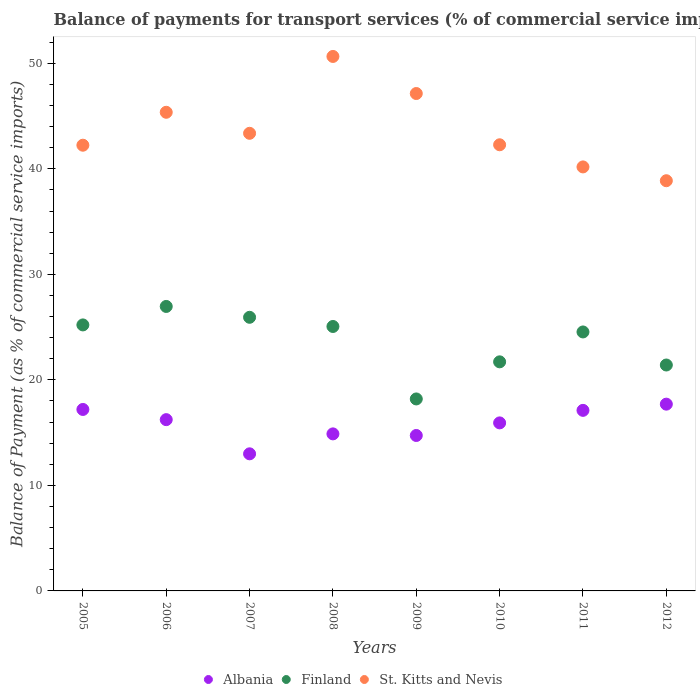Is the number of dotlines equal to the number of legend labels?
Keep it short and to the point. Yes. What is the balance of payments for transport services in Albania in 2008?
Provide a succinct answer. 14.88. Across all years, what is the maximum balance of payments for transport services in Albania?
Your answer should be very brief. 17.7. Across all years, what is the minimum balance of payments for transport services in Albania?
Offer a very short reply. 12.99. What is the total balance of payments for transport services in Albania in the graph?
Keep it short and to the point. 126.78. What is the difference between the balance of payments for transport services in Albania in 2009 and that in 2010?
Keep it short and to the point. -1.19. What is the difference between the balance of payments for transport services in St. Kitts and Nevis in 2006 and the balance of payments for transport services in Finland in 2012?
Give a very brief answer. 23.95. What is the average balance of payments for transport services in St. Kitts and Nevis per year?
Provide a short and direct response. 43.76. In the year 2012, what is the difference between the balance of payments for transport services in Albania and balance of payments for transport services in St. Kitts and Nevis?
Keep it short and to the point. -21.18. What is the ratio of the balance of payments for transport services in Finland in 2009 to that in 2011?
Provide a succinct answer. 0.74. Is the balance of payments for transport services in Albania in 2008 less than that in 2012?
Provide a succinct answer. Yes. Is the difference between the balance of payments for transport services in Albania in 2007 and 2008 greater than the difference between the balance of payments for transport services in St. Kitts and Nevis in 2007 and 2008?
Keep it short and to the point. Yes. What is the difference between the highest and the second highest balance of payments for transport services in St. Kitts and Nevis?
Give a very brief answer. 3.51. What is the difference between the highest and the lowest balance of payments for transport services in St. Kitts and Nevis?
Offer a terse response. 11.78. Is it the case that in every year, the sum of the balance of payments for transport services in Finland and balance of payments for transport services in Albania  is greater than the balance of payments for transport services in St. Kitts and Nevis?
Your answer should be compact. No. Is the balance of payments for transport services in Albania strictly greater than the balance of payments for transport services in Finland over the years?
Provide a short and direct response. No. Is the balance of payments for transport services in Finland strictly less than the balance of payments for transport services in St. Kitts and Nevis over the years?
Your answer should be compact. Yes. Are the values on the major ticks of Y-axis written in scientific E-notation?
Keep it short and to the point. No. Does the graph contain any zero values?
Your answer should be very brief. No. Where does the legend appear in the graph?
Your response must be concise. Bottom center. How are the legend labels stacked?
Keep it short and to the point. Horizontal. What is the title of the graph?
Ensure brevity in your answer.  Balance of payments for transport services (% of commercial service imports). What is the label or title of the X-axis?
Provide a succinct answer. Years. What is the label or title of the Y-axis?
Keep it short and to the point. Balance of Payment (as % of commercial service imports). What is the Balance of Payment (as % of commercial service imports) of Albania in 2005?
Your answer should be very brief. 17.2. What is the Balance of Payment (as % of commercial service imports) in Finland in 2005?
Your answer should be compact. 25.21. What is the Balance of Payment (as % of commercial service imports) in St. Kitts and Nevis in 2005?
Keep it short and to the point. 42.24. What is the Balance of Payment (as % of commercial service imports) in Albania in 2006?
Provide a succinct answer. 16.23. What is the Balance of Payment (as % of commercial service imports) in Finland in 2006?
Offer a terse response. 26.96. What is the Balance of Payment (as % of commercial service imports) in St. Kitts and Nevis in 2006?
Your answer should be compact. 45.36. What is the Balance of Payment (as % of commercial service imports) in Albania in 2007?
Offer a terse response. 12.99. What is the Balance of Payment (as % of commercial service imports) of Finland in 2007?
Your response must be concise. 25.93. What is the Balance of Payment (as % of commercial service imports) in St. Kitts and Nevis in 2007?
Provide a succinct answer. 43.37. What is the Balance of Payment (as % of commercial service imports) in Albania in 2008?
Your response must be concise. 14.88. What is the Balance of Payment (as % of commercial service imports) of Finland in 2008?
Offer a very short reply. 25.06. What is the Balance of Payment (as % of commercial service imports) of St. Kitts and Nevis in 2008?
Provide a short and direct response. 50.65. What is the Balance of Payment (as % of commercial service imports) of Albania in 2009?
Give a very brief answer. 14.73. What is the Balance of Payment (as % of commercial service imports) of Finland in 2009?
Provide a succinct answer. 18.19. What is the Balance of Payment (as % of commercial service imports) in St. Kitts and Nevis in 2009?
Provide a short and direct response. 47.14. What is the Balance of Payment (as % of commercial service imports) in Albania in 2010?
Provide a succinct answer. 15.93. What is the Balance of Payment (as % of commercial service imports) of Finland in 2010?
Your answer should be compact. 21.71. What is the Balance of Payment (as % of commercial service imports) of St. Kitts and Nevis in 2010?
Offer a terse response. 42.28. What is the Balance of Payment (as % of commercial service imports) of Albania in 2011?
Give a very brief answer. 17.11. What is the Balance of Payment (as % of commercial service imports) of Finland in 2011?
Provide a short and direct response. 24.54. What is the Balance of Payment (as % of commercial service imports) in St. Kitts and Nevis in 2011?
Keep it short and to the point. 40.18. What is the Balance of Payment (as % of commercial service imports) of Albania in 2012?
Your answer should be compact. 17.7. What is the Balance of Payment (as % of commercial service imports) of Finland in 2012?
Offer a very short reply. 21.41. What is the Balance of Payment (as % of commercial service imports) of St. Kitts and Nevis in 2012?
Make the answer very short. 38.88. Across all years, what is the maximum Balance of Payment (as % of commercial service imports) of Albania?
Ensure brevity in your answer.  17.7. Across all years, what is the maximum Balance of Payment (as % of commercial service imports) in Finland?
Your answer should be very brief. 26.96. Across all years, what is the maximum Balance of Payment (as % of commercial service imports) of St. Kitts and Nevis?
Offer a terse response. 50.65. Across all years, what is the minimum Balance of Payment (as % of commercial service imports) of Albania?
Offer a very short reply. 12.99. Across all years, what is the minimum Balance of Payment (as % of commercial service imports) of Finland?
Ensure brevity in your answer.  18.19. Across all years, what is the minimum Balance of Payment (as % of commercial service imports) in St. Kitts and Nevis?
Offer a very short reply. 38.88. What is the total Balance of Payment (as % of commercial service imports) in Albania in the graph?
Ensure brevity in your answer.  126.78. What is the total Balance of Payment (as % of commercial service imports) in Finland in the graph?
Keep it short and to the point. 189.03. What is the total Balance of Payment (as % of commercial service imports) of St. Kitts and Nevis in the graph?
Offer a very short reply. 350.11. What is the difference between the Balance of Payment (as % of commercial service imports) of Albania in 2005 and that in 2006?
Your response must be concise. 0.97. What is the difference between the Balance of Payment (as % of commercial service imports) in Finland in 2005 and that in 2006?
Provide a succinct answer. -1.75. What is the difference between the Balance of Payment (as % of commercial service imports) of St. Kitts and Nevis in 2005 and that in 2006?
Make the answer very short. -3.12. What is the difference between the Balance of Payment (as % of commercial service imports) of Albania in 2005 and that in 2007?
Ensure brevity in your answer.  4.2. What is the difference between the Balance of Payment (as % of commercial service imports) in Finland in 2005 and that in 2007?
Ensure brevity in your answer.  -0.72. What is the difference between the Balance of Payment (as % of commercial service imports) of St. Kitts and Nevis in 2005 and that in 2007?
Offer a terse response. -1.13. What is the difference between the Balance of Payment (as % of commercial service imports) of Albania in 2005 and that in 2008?
Your response must be concise. 2.31. What is the difference between the Balance of Payment (as % of commercial service imports) of Finland in 2005 and that in 2008?
Your answer should be compact. 0.15. What is the difference between the Balance of Payment (as % of commercial service imports) in St. Kitts and Nevis in 2005 and that in 2008?
Your answer should be compact. -8.41. What is the difference between the Balance of Payment (as % of commercial service imports) in Albania in 2005 and that in 2009?
Offer a terse response. 2.47. What is the difference between the Balance of Payment (as % of commercial service imports) of Finland in 2005 and that in 2009?
Ensure brevity in your answer.  7.02. What is the difference between the Balance of Payment (as % of commercial service imports) in St. Kitts and Nevis in 2005 and that in 2009?
Your answer should be very brief. -4.9. What is the difference between the Balance of Payment (as % of commercial service imports) in Albania in 2005 and that in 2010?
Make the answer very short. 1.27. What is the difference between the Balance of Payment (as % of commercial service imports) in Finland in 2005 and that in 2010?
Your answer should be compact. 3.5. What is the difference between the Balance of Payment (as % of commercial service imports) in St. Kitts and Nevis in 2005 and that in 2010?
Make the answer very short. -0.04. What is the difference between the Balance of Payment (as % of commercial service imports) in Albania in 2005 and that in 2011?
Offer a very short reply. 0.09. What is the difference between the Balance of Payment (as % of commercial service imports) of Finland in 2005 and that in 2011?
Keep it short and to the point. 0.67. What is the difference between the Balance of Payment (as % of commercial service imports) of St. Kitts and Nevis in 2005 and that in 2011?
Offer a very short reply. 2.06. What is the difference between the Balance of Payment (as % of commercial service imports) of Albania in 2005 and that in 2012?
Provide a short and direct response. -0.5. What is the difference between the Balance of Payment (as % of commercial service imports) of Finland in 2005 and that in 2012?
Your answer should be compact. 3.8. What is the difference between the Balance of Payment (as % of commercial service imports) of St. Kitts and Nevis in 2005 and that in 2012?
Provide a short and direct response. 3.37. What is the difference between the Balance of Payment (as % of commercial service imports) of Albania in 2006 and that in 2007?
Your response must be concise. 3.24. What is the difference between the Balance of Payment (as % of commercial service imports) of Finland in 2006 and that in 2007?
Keep it short and to the point. 1.03. What is the difference between the Balance of Payment (as % of commercial service imports) in St. Kitts and Nevis in 2006 and that in 2007?
Ensure brevity in your answer.  1.99. What is the difference between the Balance of Payment (as % of commercial service imports) of Albania in 2006 and that in 2008?
Your response must be concise. 1.35. What is the difference between the Balance of Payment (as % of commercial service imports) of Finland in 2006 and that in 2008?
Ensure brevity in your answer.  1.9. What is the difference between the Balance of Payment (as % of commercial service imports) in St. Kitts and Nevis in 2006 and that in 2008?
Keep it short and to the point. -5.29. What is the difference between the Balance of Payment (as % of commercial service imports) in Albania in 2006 and that in 2009?
Provide a short and direct response. 1.5. What is the difference between the Balance of Payment (as % of commercial service imports) in Finland in 2006 and that in 2009?
Keep it short and to the point. 8.77. What is the difference between the Balance of Payment (as % of commercial service imports) in St. Kitts and Nevis in 2006 and that in 2009?
Offer a terse response. -1.78. What is the difference between the Balance of Payment (as % of commercial service imports) of Albania in 2006 and that in 2010?
Provide a short and direct response. 0.31. What is the difference between the Balance of Payment (as % of commercial service imports) in Finland in 2006 and that in 2010?
Your response must be concise. 5.25. What is the difference between the Balance of Payment (as % of commercial service imports) of St. Kitts and Nevis in 2006 and that in 2010?
Offer a very short reply. 3.08. What is the difference between the Balance of Payment (as % of commercial service imports) in Albania in 2006 and that in 2011?
Provide a short and direct response. -0.88. What is the difference between the Balance of Payment (as % of commercial service imports) in Finland in 2006 and that in 2011?
Make the answer very short. 2.42. What is the difference between the Balance of Payment (as % of commercial service imports) of St. Kitts and Nevis in 2006 and that in 2011?
Offer a very short reply. 5.18. What is the difference between the Balance of Payment (as % of commercial service imports) in Albania in 2006 and that in 2012?
Your response must be concise. -1.47. What is the difference between the Balance of Payment (as % of commercial service imports) of Finland in 2006 and that in 2012?
Your answer should be very brief. 5.55. What is the difference between the Balance of Payment (as % of commercial service imports) of St. Kitts and Nevis in 2006 and that in 2012?
Your answer should be very brief. 6.49. What is the difference between the Balance of Payment (as % of commercial service imports) of Albania in 2007 and that in 2008?
Ensure brevity in your answer.  -1.89. What is the difference between the Balance of Payment (as % of commercial service imports) of Finland in 2007 and that in 2008?
Ensure brevity in your answer.  0.87. What is the difference between the Balance of Payment (as % of commercial service imports) of St. Kitts and Nevis in 2007 and that in 2008?
Give a very brief answer. -7.28. What is the difference between the Balance of Payment (as % of commercial service imports) of Albania in 2007 and that in 2009?
Ensure brevity in your answer.  -1.74. What is the difference between the Balance of Payment (as % of commercial service imports) of Finland in 2007 and that in 2009?
Provide a short and direct response. 7.74. What is the difference between the Balance of Payment (as % of commercial service imports) in St. Kitts and Nevis in 2007 and that in 2009?
Make the answer very short. -3.77. What is the difference between the Balance of Payment (as % of commercial service imports) in Albania in 2007 and that in 2010?
Make the answer very short. -2.93. What is the difference between the Balance of Payment (as % of commercial service imports) in Finland in 2007 and that in 2010?
Ensure brevity in your answer.  4.22. What is the difference between the Balance of Payment (as % of commercial service imports) of St. Kitts and Nevis in 2007 and that in 2010?
Offer a very short reply. 1.09. What is the difference between the Balance of Payment (as % of commercial service imports) in Albania in 2007 and that in 2011?
Ensure brevity in your answer.  -4.12. What is the difference between the Balance of Payment (as % of commercial service imports) in Finland in 2007 and that in 2011?
Keep it short and to the point. 1.39. What is the difference between the Balance of Payment (as % of commercial service imports) of St. Kitts and Nevis in 2007 and that in 2011?
Your response must be concise. 3.19. What is the difference between the Balance of Payment (as % of commercial service imports) of Albania in 2007 and that in 2012?
Give a very brief answer. -4.71. What is the difference between the Balance of Payment (as % of commercial service imports) in Finland in 2007 and that in 2012?
Offer a very short reply. 4.52. What is the difference between the Balance of Payment (as % of commercial service imports) in St. Kitts and Nevis in 2007 and that in 2012?
Provide a succinct answer. 4.49. What is the difference between the Balance of Payment (as % of commercial service imports) of Albania in 2008 and that in 2009?
Offer a terse response. 0.15. What is the difference between the Balance of Payment (as % of commercial service imports) in Finland in 2008 and that in 2009?
Offer a very short reply. 6.87. What is the difference between the Balance of Payment (as % of commercial service imports) of St. Kitts and Nevis in 2008 and that in 2009?
Provide a short and direct response. 3.51. What is the difference between the Balance of Payment (as % of commercial service imports) in Albania in 2008 and that in 2010?
Offer a very short reply. -1.04. What is the difference between the Balance of Payment (as % of commercial service imports) of Finland in 2008 and that in 2010?
Keep it short and to the point. 3.35. What is the difference between the Balance of Payment (as % of commercial service imports) in St. Kitts and Nevis in 2008 and that in 2010?
Provide a succinct answer. 8.37. What is the difference between the Balance of Payment (as % of commercial service imports) in Albania in 2008 and that in 2011?
Offer a terse response. -2.23. What is the difference between the Balance of Payment (as % of commercial service imports) of Finland in 2008 and that in 2011?
Provide a short and direct response. 0.52. What is the difference between the Balance of Payment (as % of commercial service imports) in St. Kitts and Nevis in 2008 and that in 2011?
Your answer should be very brief. 10.47. What is the difference between the Balance of Payment (as % of commercial service imports) of Albania in 2008 and that in 2012?
Offer a terse response. -2.82. What is the difference between the Balance of Payment (as % of commercial service imports) of Finland in 2008 and that in 2012?
Your answer should be compact. 3.65. What is the difference between the Balance of Payment (as % of commercial service imports) of St. Kitts and Nevis in 2008 and that in 2012?
Keep it short and to the point. 11.78. What is the difference between the Balance of Payment (as % of commercial service imports) in Albania in 2009 and that in 2010?
Ensure brevity in your answer.  -1.19. What is the difference between the Balance of Payment (as % of commercial service imports) of Finland in 2009 and that in 2010?
Keep it short and to the point. -3.52. What is the difference between the Balance of Payment (as % of commercial service imports) in St. Kitts and Nevis in 2009 and that in 2010?
Give a very brief answer. 4.86. What is the difference between the Balance of Payment (as % of commercial service imports) of Albania in 2009 and that in 2011?
Offer a terse response. -2.38. What is the difference between the Balance of Payment (as % of commercial service imports) of Finland in 2009 and that in 2011?
Keep it short and to the point. -6.35. What is the difference between the Balance of Payment (as % of commercial service imports) of St. Kitts and Nevis in 2009 and that in 2011?
Give a very brief answer. 6.96. What is the difference between the Balance of Payment (as % of commercial service imports) in Albania in 2009 and that in 2012?
Offer a very short reply. -2.97. What is the difference between the Balance of Payment (as % of commercial service imports) of Finland in 2009 and that in 2012?
Offer a very short reply. -3.22. What is the difference between the Balance of Payment (as % of commercial service imports) in St. Kitts and Nevis in 2009 and that in 2012?
Your answer should be very brief. 8.26. What is the difference between the Balance of Payment (as % of commercial service imports) of Albania in 2010 and that in 2011?
Keep it short and to the point. -1.19. What is the difference between the Balance of Payment (as % of commercial service imports) in Finland in 2010 and that in 2011?
Provide a succinct answer. -2.83. What is the difference between the Balance of Payment (as % of commercial service imports) of St. Kitts and Nevis in 2010 and that in 2011?
Your response must be concise. 2.1. What is the difference between the Balance of Payment (as % of commercial service imports) in Albania in 2010 and that in 2012?
Your answer should be compact. -1.78. What is the difference between the Balance of Payment (as % of commercial service imports) of Finland in 2010 and that in 2012?
Give a very brief answer. 0.3. What is the difference between the Balance of Payment (as % of commercial service imports) of St. Kitts and Nevis in 2010 and that in 2012?
Keep it short and to the point. 3.41. What is the difference between the Balance of Payment (as % of commercial service imports) of Albania in 2011 and that in 2012?
Ensure brevity in your answer.  -0.59. What is the difference between the Balance of Payment (as % of commercial service imports) of Finland in 2011 and that in 2012?
Ensure brevity in your answer.  3.13. What is the difference between the Balance of Payment (as % of commercial service imports) in St. Kitts and Nevis in 2011 and that in 2012?
Provide a short and direct response. 1.31. What is the difference between the Balance of Payment (as % of commercial service imports) in Albania in 2005 and the Balance of Payment (as % of commercial service imports) in Finland in 2006?
Keep it short and to the point. -9.76. What is the difference between the Balance of Payment (as % of commercial service imports) of Albania in 2005 and the Balance of Payment (as % of commercial service imports) of St. Kitts and Nevis in 2006?
Give a very brief answer. -28.16. What is the difference between the Balance of Payment (as % of commercial service imports) of Finland in 2005 and the Balance of Payment (as % of commercial service imports) of St. Kitts and Nevis in 2006?
Ensure brevity in your answer.  -20.15. What is the difference between the Balance of Payment (as % of commercial service imports) in Albania in 2005 and the Balance of Payment (as % of commercial service imports) in Finland in 2007?
Offer a terse response. -8.73. What is the difference between the Balance of Payment (as % of commercial service imports) in Albania in 2005 and the Balance of Payment (as % of commercial service imports) in St. Kitts and Nevis in 2007?
Your answer should be very brief. -26.17. What is the difference between the Balance of Payment (as % of commercial service imports) in Finland in 2005 and the Balance of Payment (as % of commercial service imports) in St. Kitts and Nevis in 2007?
Ensure brevity in your answer.  -18.16. What is the difference between the Balance of Payment (as % of commercial service imports) of Albania in 2005 and the Balance of Payment (as % of commercial service imports) of Finland in 2008?
Your answer should be very brief. -7.86. What is the difference between the Balance of Payment (as % of commercial service imports) in Albania in 2005 and the Balance of Payment (as % of commercial service imports) in St. Kitts and Nevis in 2008?
Provide a succinct answer. -33.46. What is the difference between the Balance of Payment (as % of commercial service imports) in Finland in 2005 and the Balance of Payment (as % of commercial service imports) in St. Kitts and Nevis in 2008?
Your answer should be very brief. -25.44. What is the difference between the Balance of Payment (as % of commercial service imports) in Albania in 2005 and the Balance of Payment (as % of commercial service imports) in Finland in 2009?
Offer a very short reply. -1. What is the difference between the Balance of Payment (as % of commercial service imports) in Albania in 2005 and the Balance of Payment (as % of commercial service imports) in St. Kitts and Nevis in 2009?
Offer a terse response. -29.94. What is the difference between the Balance of Payment (as % of commercial service imports) of Finland in 2005 and the Balance of Payment (as % of commercial service imports) of St. Kitts and Nevis in 2009?
Your response must be concise. -21.93. What is the difference between the Balance of Payment (as % of commercial service imports) of Albania in 2005 and the Balance of Payment (as % of commercial service imports) of Finland in 2010?
Provide a short and direct response. -4.51. What is the difference between the Balance of Payment (as % of commercial service imports) of Albania in 2005 and the Balance of Payment (as % of commercial service imports) of St. Kitts and Nevis in 2010?
Make the answer very short. -25.08. What is the difference between the Balance of Payment (as % of commercial service imports) in Finland in 2005 and the Balance of Payment (as % of commercial service imports) in St. Kitts and Nevis in 2010?
Your answer should be compact. -17.07. What is the difference between the Balance of Payment (as % of commercial service imports) of Albania in 2005 and the Balance of Payment (as % of commercial service imports) of Finland in 2011?
Offer a very short reply. -7.35. What is the difference between the Balance of Payment (as % of commercial service imports) of Albania in 2005 and the Balance of Payment (as % of commercial service imports) of St. Kitts and Nevis in 2011?
Give a very brief answer. -22.99. What is the difference between the Balance of Payment (as % of commercial service imports) of Finland in 2005 and the Balance of Payment (as % of commercial service imports) of St. Kitts and Nevis in 2011?
Make the answer very short. -14.97. What is the difference between the Balance of Payment (as % of commercial service imports) in Albania in 2005 and the Balance of Payment (as % of commercial service imports) in Finland in 2012?
Give a very brief answer. -4.21. What is the difference between the Balance of Payment (as % of commercial service imports) of Albania in 2005 and the Balance of Payment (as % of commercial service imports) of St. Kitts and Nevis in 2012?
Make the answer very short. -21.68. What is the difference between the Balance of Payment (as % of commercial service imports) of Finland in 2005 and the Balance of Payment (as % of commercial service imports) of St. Kitts and Nevis in 2012?
Keep it short and to the point. -13.67. What is the difference between the Balance of Payment (as % of commercial service imports) in Albania in 2006 and the Balance of Payment (as % of commercial service imports) in St. Kitts and Nevis in 2007?
Give a very brief answer. -27.14. What is the difference between the Balance of Payment (as % of commercial service imports) in Finland in 2006 and the Balance of Payment (as % of commercial service imports) in St. Kitts and Nevis in 2007?
Your answer should be very brief. -16.41. What is the difference between the Balance of Payment (as % of commercial service imports) of Albania in 2006 and the Balance of Payment (as % of commercial service imports) of Finland in 2008?
Make the answer very short. -8.83. What is the difference between the Balance of Payment (as % of commercial service imports) in Albania in 2006 and the Balance of Payment (as % of commercial service imports) in St. Kitts and Nevis in 2008?
Offer a very short reply. -34.42. What is the difference between the Balance of Payment (as % of commercial service imports) in Finland in 2006 and the Balance of Payment (as % of commercial service imports) in St. Kitts and Nevis in 2008?
Your answer should be compact. -23.69. What is the difference between the Balance of Payment (as % of commercial service imports) in Albania in 2006 and the Balance of Payment (as % of commercial service imports) in Finland in 2009?
Offer a very short reply. -1.96. What is the difference between the Balance of Payment (as % of commercial service imports) in Albania in 2006 and the Balance of Payment (as % of commercial service imports) in St. Kitts and Nevis in 2009?
Keep it short and to the point. -30.91. What is the difference between the Balance of Payment (as % of commercial service imports) in Finland in 2006 and the Balance of Payment (as % of commercial service imports) in St. Kitts and Nevis in 2009?
Provide a succinct answer. -20.18. What is the difference between the Balance of Payment (as % of commercial service imports) of Albania in 2006 and the Balance of Payment (as % of commercial service imports) of Finland in 2010?
Provide a succinct answer. -5.48. What is the difference between the Balance of Payment (as % of commercial service imports) in Albania in 2006 and the Balance of Payment (as % of commercial service imports) in St. Kitts and Nevis in 2010?
Keep it short and to the point. -26.05. What is the difference between the Balance of Payment (as % of commercial service imports) in Finland in 2006 and the Balance of Payment (as % of commercial service imports) in St. Kitts and Nevis in 2010?
Offer a terse response. -15.32. What is the difference between the Balance of Payment (as % of commercial service imports) in Albania in 2006 and the Balance of Payment (as % of commercial service imports) in Finland in 2011?
Provide a short and direct response. -8.31. What is the difference between the Balance of Payment (as % of commercial service imports) of Albania in 2006 and the Balance of Payment (as % of commercial service imports) of St. Kitts and Nevis in 2011?
Ensure brevity in your answer.  -23.95. What is the difference between the Balance of Payment (as % of commercial service imports) in Finland in 2006 and the Balance of Payment (as % of commercial service imports) in St. Kitts and Nevis in 2011?
Make the answer very short. -13.22. What is the difference between the Balance of Payment (as % of commercial service imports) of Albania in 2006 and the Balance of Payment (as % of commercial service imports) of Finland in 2012?
Your response must be concise. -5.18. What is the difference between the Balance of Payment (as % of commercial service imports) in Albania in 2006 and the Balance of Payment (as % of commercial service imports) in St. Kitts and Nevis in 2012?
Provide a succinct answer. -22.64. What is the difference between the Balance of Payment (as % of commercial service imports) of Finland in 2006 and the Balance of Payment (as % of commercial service imports) of St. Kitts and Nevis in 2012?
Your answer should be compact. -11.92. What is the difference between the Balance of Payment (as % of commercial service imports) in Albania in 2007 and the Balance of Payment (as % of commercial service imports) in Finland in 2008?
Ensure brevity in your answer.  -12.07. What is the difference between the Balance of Payment (as % of commercial service imports) in Albania in 2007 and the Balance of Payment (as % of commercial service imports) in St. Kitts and Nevis in 2008?
Your answer should be very brief. -37.66. What is the difference between the Balance of Payment (as % of commercial service imports) in Finland in 2007 and the Balance of Payment (as % of commercial service imports) in St. Kitts and Nevis in 2008?
Keep it short and to the point. -24.72. What is the difference between the Balance of Payment (as % of commercial service imports) of Albania in 2007 and the Balance of Payment (as % of commercial service imports) of Finland in 2009?
Provide a succinct answer. -5.2. What is the difference between the Balance of Payment (as % of commercial service imports) in Albania in 2007 and the Balance of Payment (as % of commercial service imports) in St. Kitts and Nevis in 2009?
Provide a short and direct response. -34.15. What is the difference between the Balance of Payment (as % of commercial service imports) of Finland in 2007 and the Balance of Payment (as % of commercial service imports) of St. Kitts and Nevis in 2009?
Make the answer very short. -21.21. What is the difference between the Balance of Payment (as % of commercial service imports) of Albania in 2007 and the Balance of Payment (as % of commercial service imports) of Finland in 2010?
Your answer should be very brief. -8.72. What is the difference between the Balance of Payment (as % of commercial service imports) in Albania in 2007 and the Balance of Payment (as % of commercial service imports) in St. Kitts and Nevis in 2010?
Your answer should be very brief. -29.29. What is the difference between the Balance of Payment (as % of commercial service imports) in Finland in 2007 and the Balance of Payment (as % of commercial service imports) in St. Kitts and Nevis in 2010?
Give a very brief answer. -16.35. What is the difference between the Balance of Payment (as % of commercial service imports) in Albania in 2007 and the Balance of Payment (as % of commercial service imports) in Finland in 2011?
Keep it short and to the point. -11.55. What is the difference between the Balance of Payment (as % of commercial service imports) of Albania in 2007 and the Balance of Payment (as % of commercial service imports) of St. Kitts and Nevis in 2011?
Keep it short and to the point. -27.19. What is the difference between the Balance of Payment (as % of commercial service imports) of Finland in 2007 and the Balance of Payment (as % of commercial service imports) of St. Kitts and Nevis in 2011?
Ensure brevity in your answer.  -14.25. What is the difference between the Balance of Payment (as % of commercial service imports) of Albania in 2007 and the Balance of Payment (as % of commercial service imports) of Finland in 2012?
Keep it short and to the point. -8.42. What is the difference between the Balance of Payment (as % of commercial service imports) in Albania in 2007 and the Balance of Payment (as % of commercial service imports) in St. Kitts and Nevis in 2012?
Give a very brief answer. -25.88. What is the difference between the Balance of Payment (as % of commercial service imports) of Finland in 2007 and the Balance of Payment (as % of commercial service imports) of St. Kitts and Nevis in 2012?
Your response must be concise. -12.94. What is the difference between the Balance of Payment (as % of commercial service imports) in Albania in 2008 and the Balance of Payment (as % of commercial service imports) in Finland in 2009?
Offer a terse response. -3.31. What is the difference between the Balance of Payment (as % of commercial service imports) of Albania in 2008 and the Balance of Payment (as % of commercial service imports) of St. Kitts and Nevis in 2009?
Keep it short and to the point. -32.26. What is the difference between the Balance of Payment (as % of commercial service imports) of Finland in 2008 and the Balance of Payment (as % of commercial service imports) of St. Kitts and Nevis in 2009?
Make the answer very short. -22.08. What is the difference between the Balance of Payment (as % of commercial service imports) in Albania in 2008 and the Balance of Payment (as % of commercial service imports) in Finland in 2010?
Keep it short and to the point. -6.83. What is the difference between the Balance of Payment (as % of commercial service imports) of Albania in 2008 and the Balance of Payment (as % of commercial service imports) of St. Kitts and Nevis in 2010?
Provide a succinct answer. -27.4. What is the difference between the Balance of Payment (as % of commercial service imports) in Finland in 2008 and the Balance of Payment (as % of commercial service imports) in St. Kitts and Nevis in 2010?
Your answer should be very brief. -17.22. What is the difference between the Balance of Payment (as % of commercial service imports) of Albania in 2008 and the Balance of Payment (as % of commercial service imports) of Finland in 2011?
Offer a terse response. -9.66. What is the difference between the Balance of Payment (as % of commercial service imports) of Albania in 2008 and the Balance of Payment (as % of commercial service imports) of St. Kitts and Nevis in 2011?
Make the answer very short. -25.3. What is the difference between the Balance of Payment (as % of commercial service imports) of Finland in 2008 and the Balance of Payment (as % of commercial service imports) of St. Kitts and Nevis in 2011?
Your response must be concise. -15.12. What is the difference between the Balance of Payment (as % of commercial service imports) of Albania in 2008 and the Balance of Payment (as % of commercial service imports) of Finland in 2012?
Your answer should be compact. -6.53. What is the difference between the Balance of Payment (as % of commercial service imports) in Albania in 2008 and the Balance of Payment (as % of commercial service imports) in St. Kitts and Nevis in 2012?
Offer a very short reply. -23.99. What is the difference between the Balance of Payment (as % of commercial service imports) in Finland in 2008 and the Balance of Payment (as % of commercial service imports) in St. Kitts and Nevis in 2012?
Offer a terse response. -13.81. What is the difference between the Balance of Payment (as % of commercial service imports) of Albania in 2009 and the Balance of Payment (as % of commercial service imports) of Finland in 2010?
Your answer should be compact. -6.98. What is the difference between the Balance of Payment (as % of commercial service imports) of Albania in 2009 and the Balance of Payment (as % of commercial service imports) of St. Kitts and Nevis in 2010?
Ensure brevity in your answer.  -27.55. What is the difference between the Balance of Payment (as % of commercial service imports) in Finland in 2009 and the Balance of Payment (as % of commercial service imports) in St. Kitts and Nevis in 2010?
Offer a terse response. -24.09. What is the difference between the Balance of Payment (as % of commercial service imports) of Albania in 2009 and the Balance of Payment (as % of commercial service imports) of Finland in 2011?
Your answer should be very brief. -9.81. What is the difference between the Balance of Payment (as % of commercial service imports) in Albania in 2009 and the Balance of Payment (as % of commercial service imports) in St. Kitts and Nevis in 2011?
Offer a very short reply. -25.45. What is the difference between the Balance of Payment (as % of commercial service imports) of Finland in 2009 and the Balance of Payment (as % of commercial service imports) of St. Kitts and Nevis in 2011?
Provide a succinct answer. -21.99. What is the difference between the Balance of Payment (as % of commercial service imports) in Albania in 2009 and the Balance of Payment (as % of commercial service imports) in Finland in 2012?
Make the answer very short. -6.68. What is the difference between the Balance of Payment (as % of commercial service imports) in Albania in 2009 and the Balance of Payment (as % of commercial service imports) in St. Kitts and Nevis in 2012?
Your response must be concise. -24.14. What is the difference between the Balance of Payment (as % of commercial service imports) in Finland in 2009 and the Balance of Payment (as % of commercial service imports) in St. Kitts and Nevis in 2012?
Your response must be concise. -20.68. What is the difference between the Balance of Payment (as % of commercial service imports) in Albania in 2010 and the Balance of Payment (as % of commercial service imports) in Finland in 2011?
Offer a very short reply. -8.62. What is the difference between the Balance of Payment (as % of commercial service imports) in Albania in 2010 and the Balance of Payment (as % of commercial service imports) in St. Kitts and Nevis in 2011?
Ensure brevity in your answer.  -24.26. What is the difference between the Balance of Payment (as % of commercial service imports) in Finland in 2010 and the Balance of Payment (as % of commercial service imports) in St. Kitts and Nevis in 2011?
Ensure brevity in your answer.  -18.47. What is the difference between the Balance of Payment (as % of commercial service imports) in Albania in 2010 and the Balance of Payment (as % of commercial service imports) in Finland in 2012?
Your response must be concise. -5.49. What is the difference between the Balance of Payment (as % of commercial service imports) in Albania in 2010 and the Balance of Payment (as % of commercial service imports) in St. Kitts and Nevis in 2012?
Your answer should be very brief. -22.95. What is the difference between the Balance of Payment (as % of commercial service imports) in Finland in 2010 and the Balance of Payment (as % of commercial service imports) in St. Kitts and Nevis in 2012?
Offer a very short reply. -17.17. What is the difference between the Balance of Payment (as % of commercial service imports) in Albania in 2011 and the Balance of Payment (as % of commercial service imports) in Finland in 2012?
Provide a short and direct response. -4.3. What is the difference between the Balance of Payment (as % of commercial service imports) in Albania in 2011 and the Balance of Payment (as % of commercial service imports) in St. Kitts and Nevis in 2012?
Offer a terse response. -21.76. What is the difference between the Balance of Payment (as % of commercial service imports) in Finland in 2011 and the Balance of Payment (as % of commercial service imports) in St. Kitts and Nevis in 2012?
Ensure brevity in your answer.  -14.33. What is the average Balance of Payment (as % of commercial service imports) in Albania per year?
Your answer should be very brief. 15.85. What is the average Balance of Payment (as % of commercial service imports) in Finland per year?
Provide a succinct answer. 23.63. What is the average Balance of Payment (as % of commercial service imports) of St. Kitts and Nevis per year?
Your response must be concise. 43.76. In the year 2005, what is the difference between the Balance of Payment (as % of commercial service imports) of Albania and Balance of Payment (as % of commercial service imports) of Finland?
Your answer should be compact. -8.01. In the year 2005, what is the difference between the Balance of Payment (as % of commercial service imports) of Albania and Balance of Payment (as % of commercial service imports) of St. Kitts and Nevis?
Keep it short and to the point. -25.04. In the year 2005, what is the difference between the Balance of Payment (as % of commercial service imports) in Finland and Balance of Payment (as % of commercial service imports) in St. Kitts and Nevis?
Make the answer very short. -17.03. In the year 2006, what is the difference between the Balance of Payment (as % of commercial service imports) in Albania and Balance of Payment (as % of commercial service imports) in Finland?
Ensure brevity in your answer.  -10.73. In the year 2006, what is the difference between the Balance of Payment (as % of commercial service imports) in Albania and Balance of Payment (as % of commercial service imports) in St. Kitts and Nevis?
Your response must be concise. -29.13. In the year 2006, what is the difference between the Balance of Payment (as % of commercial service imports) of Finland and Balance of Payment (as % of commercial service imports) of St. Kitts and Nevis?
Offer a very short reply. -18.4. In the year 2007, what is the difference between the Balance of Payment (as % of commercial service imports) in Albania and Balance of Payment (as % of commercial service imports) in Finland?
Your answer should be compact. -12.94. In the year 2007, what is the difference between the Balance of Payment (as % of commercial service imports) in Albania and Balance of Payment (as % of commercial service imports) in St. Kitts and Nevis?
Provide a succinct answer. -30.38. In the year 2007, what is the difference between the Balance of Payment (as % of commercial service imports) of Finland and Balance of Payment (as % of commercial service imports) of St. Kitts and Nevis?
Offer a very short reply. -17.44. In the year 2008, what is the difference between the Balance of Payment (as % of commercial service imports) of Albania and Balance of Payment (as % of commercial service imports) of Finland?
Make the answer very short. -10.18. In the year 2008, what is the difference between the Balance of Payment (as % of commercial service imports) of Albania and Balance of Payment (as % of commercial service imports) of St. Kitts and Nevis?
Ensure brevity in your answer.  -35.77. In the year 2008, what is the difference between the Balance of Payment (as % of commercial service imports) in Finland and Balance of Payment (as % of commercial service imports) in St. Kitts and Nevis?
Your answer should be very brief. -25.59. In the year 2009, what is the difference between the Balance of Payment (as % of commercial service imports) of Albania and Balance of Payment (as % of commercial service imports) of Finland?
Make the answer very short. -3.46. In the year 2009, what is the difference between the Balance of Payment (as % of commercial service imports) of Albania and Balance of Payment (as % of commercial service imports) of St. Kitts and Nevis?
Your answer should be compact. -32.41. In the year 2009, what is the difference between the Balance of Payment (as % of commercial service imports) of Finland and Balance of Payment (as % of commercial service imports) of St. Kitts and Nevis?
Make the answer very short. -28.95. In the year 2010, what is the difference between the Balance of Payment (as % of commercial service imports) of Albania and Balance of Payment (as % of commercial service imports) of Finland?
Ensure brevity in your answer.  -5.79. In the year 2010, what is the difference between the Balance of Payment (as % of commercial service imports) in Albania and Balance of Payment (as % of commercial service imports) in St. Kitts and Nevis?
Keep it short and to the point. -26.36. In the year 2010, what is the difference between the Balance of Payment (as % of commercial service imports) in Finland and Balance of Payment (as % of commercial service imports) in St. Kitts and Nevis?
Your answer should be very brief. -20.57. In the year 2011, what is the difference between the Balance of Payment (as % of commercial service imports) of Albania and Balance of Payment (as % of commercial service imports) of Finland?
Provide a short and direct response. -7.43. In the year 2011, what is the difference between the Balance of Payment (as % of commercial service imports) of Albania and Balance of Payment (as % of commercial service imports) of St. Kitts and Nevis?
Keep it short and to the point. -23.07. In the year 2011, what is the difference between the Balance of Payment (as % of commercial service imports) of Finland and Balance of Payment (as % of commercial service imports) of St. Kitts and Nevis?
Provide a succinct answer. -15.64. In the year 2012, what is the difference between the Balance of Payment (as % of commercial service imports) of Albania and Balance of Payment (as % of commercial service imports) of Finland?
Offer a terse response. -3.71. In the year 2012, what is the difference between the Balance of Payment (as % of commercial service imports) of Albania and Balance of Payment (as % of commercial service imports) of St. Kitts and Nevis?
Your answer should be compact. -21.18. In the year 2012, what is the difference between the Balance of Payment (as % of commercial service imports) of Finland and Balance of Payment (as % of commercial service imports) of St. Kitts and Nevis?
Provide a succinct answer. -17.47. What is the ratio of the Balance of Payment (as % of commercial service imports) of Albania in 2005 to that in 2006?
Keep it short and to the point. 1.06. What is the ratio of the Balance of Payment (as % of commercial service imports) of Finland in 2005 to that in 2006?
Ensure brevity in your answer.  0.94. What is the ratio of the Balance of Payment (as % of commercial service imports) of St. Kitts and Nevis in 2005 to that in 2006?
Keep it short and to the point. 0.93. What is the ratio of the Balance of Payment (as % of commercial service imports) in Albania in 2005 to that in 2007?
Your answer should be compact. 1.32. What is the ratio of the Balance of Payment (as % of commercial service imports) of Finland in 2005 to that in 2007?
Provide a short and direct response. 0.97. What is the ratio of the Balance of Payment (as % of commercial service imports) of Albania in 2005 to that in 2008?
Offer a very short reply. 1.16. What is the ratio of the Balance of Payment (as % of commercial service imports) of Finland in 2005 to that in 2008?
Ensure brevity in your answer.  1.01. What is the ratio of the Balance of Payment (as % of commercial service imports) of St. Kitts and Nevis in 2005 to that in 2008?
Provide a short and direct response. 0.83. What is the ratio of the Balance of Payment (as % of commercial service imports) in Albania in 2005 to that in 2009?
Provide a short and direct response. 1.17. What is the ratio of the Balance of Payment (as % of commercial service imports) of Finland in 2005 to that in 2009?
Give a very brief answer. 1.39. What is the ratio of the Balance of Payment (as % of commercial service imports) in St. Kitts and Nevis in 2005 to that in 2009?
Offer a very short reply. 0.9. What is the ratio of the Balance of Payment (as % of commercial service imports) of Albania in 2005 to that in 2010?
Keep it short and to the point. 1.08. What is the ratio of the Balance of Payment (as % of commercial service imports) in Finland in 2005 to that in 2010?
Your answer should be very brief. 1.16. What is the ratio of the Balance of Payment (as % of commercial service imports) in St. Kitts and Nevis in 2005 to that in 2010?
Your answer should be very brief. 1. What is the ratio of the Balance of Payment (as % of commercial service imports) in Albania in 2005 to that in 2011?
Your answer should be very brief. 1. What is the ratio of the Balance of Payment (as % of commercial service imports) in Finland in 2005 to that in 2011?
Your response must be concise. 1.03. What is the ratio of the Balance of Payment (as % of commercial service imports) in St. Kitts and Nevis in 2005 to that in 2011?
Your answer should be compact. 1.05. What is the ratio of the Balance of Payment (as % of commercial service imports) of Albania in 2005 to that in 2012?
Provide a succinct answer. 0.97. What is the ratio of the Balance of Payment (as % of commercial service imports) of Finland in 2005 to that in 2012?
Your response must be concise. 1.18. What is the ratio of the Balance of Payment (as % of commercial service imports) of St. Kitts and Nevis in 2005 to that in 2012?
Your answer should be compact. 1.09. What is the ratio of the Balance of Payment (as % of commercial service imports) of Albania in 2006 to that in 2007?
Provide a succinct answer. 1.25. What is the ratio of the Balance of Payment (as % of commercial service imports) in Finland in 2006 to that in 2007?
Provide a succinct answer. 1.04. What is the ratio of the Balance of Payment (as % of commercial service imports) in St. Kitts and Nevis in 2006 to that in 2007?
Your answer should be very brief. 1.05. What is the ratio of the Balance of Payment (as % of commercial service imports) in Albania in 2006 to that in 2008?
Provide a short and direct response. 1.09. What is the ratio of the Balance of Payment (as % of commercial service imports) in Finland in 2006 to that in 2008?
Your answer should be compact. 1.08. What is the ratio of the Balance of Payment (as % of commercial service imports) of St. Kitts and Nevis in 2006 to that in 2008?
Ensure brevity in your answer.  0.9. What is the ratio of the Balance of Payment (as % of commercial service imports) of Albania in 2006 to that in 2009?
Keep it short and to the point. 1.1. What is the ratio of the Balance of Payment (as % of commercial service imports) in Finland in 2006 to that in 2009?
Offer a terse response. 1.48. What is the ratio of the Balance of Payment (as % of commercial service imports) in St. Kitts and Nevis in 2006 to that in 2009?
Give a very brief answer. 0.96. What is the ratio of the Balance of Payment (as % of commercial service imports) of Albania in 2006 to that in 2010?
Make the answer very short. 1.02. What is the ratio of the Balance of Payment (as % of commercial service imports) in Finland in 2006 to that in 2010?
Provide a short and direct response. 1.24. What is the ratio of the Balance of Payment (as % of commercial service imports) in St. Kitts and Nevis in 2006 to that in 2010?
Provide a short and direct response. 1.07. What is the ratio of the Balance of Payment (as % of commercial service imports) of Albania in 2006 to that in 2011?
Offer a very short reply. 0.95. What is the ratio of the Balance of Payment (as % of commercial service imports) of Finland in 2006 to that in 2011?
Make the answer very short. 1.1. What is the ratio of the Balance of Payment (as % of commercial service imports) in St. Kitts and Nevis in 2006 to that in 2011?
Give a very brief answer. 1.13. What is the ratio of the Balance of Payment (as % of commercial service imports) in Albania in 2006 to that in 2012?
Your answer should be very brief. 0.92. What is the ratio of the Balance of Payment (as % of commercial service imports) in Finland in 2006 to that in 2012?
Give a very brief answer. 1.26. What is the ratio of the Balance of Payment (as % of commercial service imports) in St. Kitts and Nevis in 2006 to that in 2012?
Offer a terse response. 1.17. What is the ratio of the Balance of Payment (as % of commercial service imports) in Albania in 2007 to that in 2008?
Your answer should be very brief. 0.87. What is the ratio of the Balance of Payment (as % of commercial service imports) in Finland in 2007 to that in 2008?
Make the answer very short. 1.03. What is the ratio of the Balance of Payment (as % of commercial service imports) of St. Kitts and Nevis in 2007 to that in 2008?
Provide a short and direct response. 0.86. What is the ratio of the Balance of Payment (as % of commercial service imports) in Albania in 2007 to that in 2009?
Provide a succinct answer. 0.88. What is the ratio of the Balance of Payment (as % of commercial service imports) in Finland in 2007 to that in 2009?
Make the answer very short. 1.43. What is the ratio of the Balance of Payment (as % of commercial service imports) in St. Kitts and Nevis in 2007 to that in 2009?
Keep it short and to the point. 0.92. What is the ratio of the Balance of Payment (as % of commercial service imports) of Albania in 2007 to that in 2010?
Your response must be concise. 0.82. What is the ratio of the Balance of Payment (as % of commercial service imports) in Finland in 2007 to that in 2010?
Offer a very short reply. 1.19. What is the ratio of the Balance of Payment (as % of commercial service imports) of St. Kitts and Nevis in 2007 to that in 2010?
Provide a succinct answer. 1.03. What is the ratio of the Balance of Payment (as % of commercial service imports) of Albania in 2007 to that in 2011?
Keep it short and to the point. 0.76. What is the ratio of the Balance of Payment (as % of commercial service imports) in Finland in 2007 to that in 2011?
Your response must be concise. 1.06. What is the ratio of the Balance of Payment (as % of commercial service imports) in St. Kitts and Nevis in 2007 to that in 2011?
Provide a short and direct response. 1.08. What is the ratio of the Balance of Payment (as % of commercial service imports) of Albania in 2007 to that in 2012?
Your response must be concise. 0.73. What is the ratio of the Balance of Payment (as % of commercial service imports) in Finland in 2007 to that in 2012?
Make the answer very short. 1.21. What is the ratio of the Balance of Payment (as % of commercial service imports) of St. Kitts and Nevis in 2007 to that in 2012?
Offer a very short reply. 1.12. What is the ratio of the Balance of Payment (as % of commercial service imports) in Albania in 2008 to that in 2009?
Offer a very short reply. 1.01. What is the ratio of the Balance of Payment (as % of commercial service imports) of Finland in 2008 to that in 2009?
Offer a very short reply. 1.38. What is the ratio of the Balance of Payment (as % of commercial service imports) of St. Kitts and Nevis in 2008 to that in 2009?
Offer a terse response. 1.07. What is the ratio of the Balance of Payment (as % of commercial service imports) in Albania in 2008 to that in 2010?
Keep it short and to the point. 0.93. What is the ratio of the Balance of Payment (as % of commercial service imports) in Finland in 2008 to that in 2010?
Offer a terse response. 1.15. What is the ratio of the Balance of Payment (as % of commercial service imports) of St. Kitts and Nevis in 2008 to that in 2010?
Give a very brief answer. 1.2. What is the ratio of the Balance of Payment (as % of commercial service imports) in Albania in 2008 to that in 2011?
Your response must be concise. 0.87. What is the ratio of the Balance of Payment (as % of commercial service imports) in Finland in 2008 to that in 2011?
Offer a terse response. 1.02. What is the ratio of the Balance of Payment (as % of commercial service imports) in St. Kitts and Nevis in 2008 to that in 2011?
Provide a succinct answer. 1.26. What is the ratio of the Balance of Payment (as % of commercial service imports) in Albania in 2008 to that in 2012?
Your answer should be compact. 0.84. What is the ratio of the Balance of Payment (as % of commercial service imports) of Finland in 2008 to that in 2012?
Keep it short and to the point. 1.17. What is the ratio of the Balance of Payment (as % of commercial service imports) in St. Kitts and Nevis in 2008 to that in 2012?
Make the answer very short. 1.3. What is the ratio of the Balance of Payment (as % of commercial service imports) in Albania in 2009 to that in 2010?
Your response must be concise. 0.93. What is the ratio of the Balance of Payment (as % of commercial service imports) of Finland in 2009 to that in 2010?
Your answer should be very brief. 0.84. What is the ratio of the Balance of Payment (as % of commercial service imports) in St. Kitts and Nevis in 2009 to that in 2010?
Your response must be concise. 1.11. What is the ratio of the Balance of Payment (as % of commercial service imports) of Albania in 2009 to that in 2011?
Ensure brevity in your answer.  0.86. What is the ratio of the Balance of Payment (as % of commercial service imports) of Finland in 2009 to that in 2011?
Provide a short and direct response. 0.74. What is the ratio of the Balance of Payment (as % of commercial service imports) in St. Kitts and Nevis in 2009 to that in 2011?
Your answer should be very brief. 1.17. What is the ratio of the Balance of Payment (as % of commercial service imports) of Albania in 2009 to that in 2012?
Your answer should be very brief. 0.83. What is the ratio of the Balance of Payment (as % of commercial service imports) in Finland in 2009 to that in 2012?
Provide a succinct answer. 0.85. What is the ratio of the Balance of Payment (as % of commercial service imports) in St. Kitts and Nevis in 2009 to that in 2012?
Provide a succinct answer. 1.21. What is the ratio of the Balance of Payment (as % of commercial service imports) of Albania in 2010 to that in 2011?
Give a very brief answer. 0.93. What is the ratio of the Balance of Payment (as % of commercial service imports) of Finland in 2010 to that in 2011?
Keep it short and to the point. 0.88. What is the ratio of the Balance of Payment (as % of commercial service imports) of St. Kitts and Nevis in 2010 to that in 2011?
Ensure brevity in your answer.  1.05. What is the ratio of the Balance of Payment (as % of commercial service imports) in Albania in 2010 to that in 2012?
Offer a terse response. 0.9. What is the ratio of the Balance of Payment (as % of commercial service imports) of Finland in 2010 to that in 2012?
Offer a terse response. 1.01. What is the ratio of the Balance of Payment (as % of commercial service imports) in St. Kitts and Nevis in 2010 to that in 2012?
Your response must be concise. 1.09. What is the ratio of the Balance of Payment (as % of commercial service imports) of Albania in 2011 to that in 2012?
Provide a short and direct response. 0.97. What is the ratio of the Balance of Payment (as % of commercial service imports) of Finland in 2011 to that in 2012?
Your answer should be very brief. 1.15. What is the ratio of the Balance of Payment (as % of commercial service imports) of St. Kitts and Nevis in 2011 to that in 2012?
Provide a short and direct response. 1.03. What is the difference between the highest and the second highest Balance of Payment (as % of commercial service imports) in Albania?
Provide a short and direct response. 0.5. What is the difference between the highest and the second highest Balance of Payment (as % of commercial service imports) of Finland?
Provide a succinct answer. 1.03. What is the difference between the highest and the second highest Balance of Payment (as % of commercial service imports) in St. Kitts and Nevis?
Give a very brief answer. 3.51. What is the difference between the highest and the lowest Balance of Payment (as % of commercial service imports) in Albania?
Your answer should be very brief. 4.71. What is the difference between the highest and the lowest Balance of Payment (as % of commercial service imports) of Finland?
Your response must be concise. 8.77. What is the difference between the highest and the lowest Balance of Payment (as % of commercial service imports) of St. Kitts and Nevis?
Your response must be concise. 11.78. 